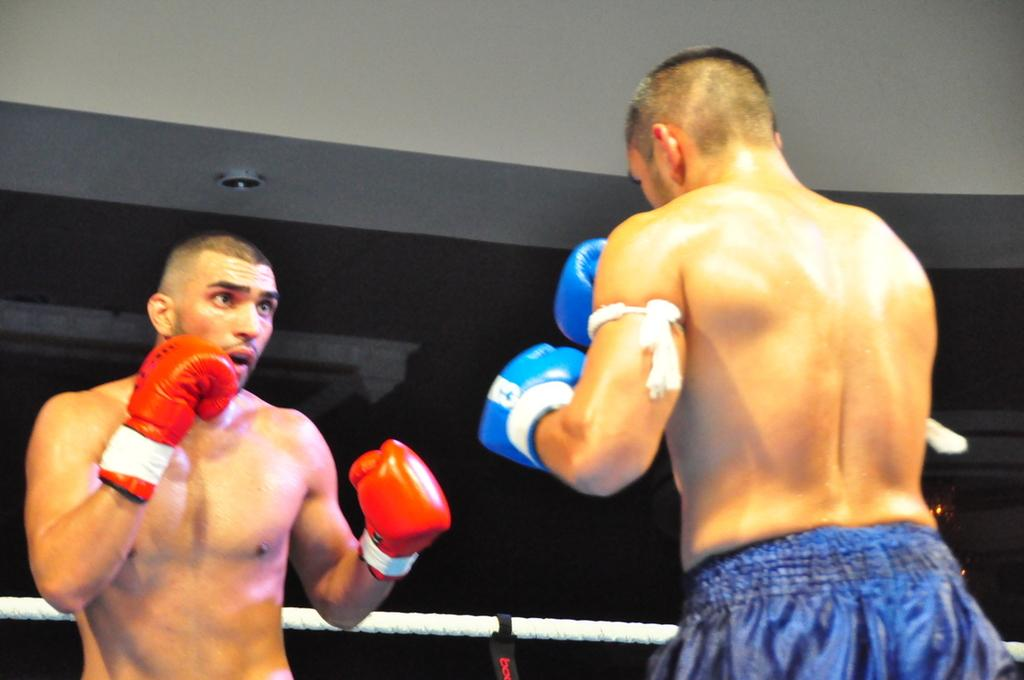How many people are in the image? There are two persons in the image. What are the persons wearing on their hands? The persons are wearing boxing gloves. Can you describe anything in the background of the image? There is a rope visible in the background of the image. What is the manager's reaction to the surprise in the image? There is no manager or surprise present in the image. 